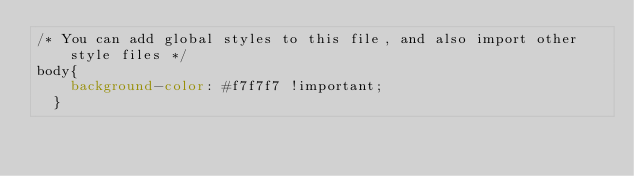Convert code to text. <code><loc_0><loc_0><loc_500><loc_500><_CSS_>/* You can add global styles to this file, and also import other style files */
body{
    background-color: #f7f7f7 !important;
  }</code> 